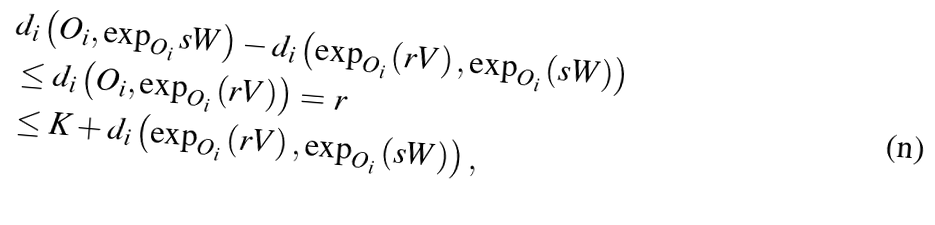<formula> <loc_0><loc_0><loc_500><loc_500>& d _ { i } \left ( O _ { i } , \exp _ { O _ { i } } s W \right ) - d _ { i } \left ( \exp _ { O _ { i } } \left ( r V \right ) , \exp _ { O _ { i } } \left ( s W \right ) \right ) \\ & \leq d _ { i } \left ( O _ { i } , \exp _ { O _ { i } } \left ( r V \right ) \right ) = r \\ & \leq K + d _ { i } \left ( \exp _ { O _ { i } } \left ( r V \right ) , \exp _ { O _ { i } } \left ( s W \right ) \right ) ,</formula> 